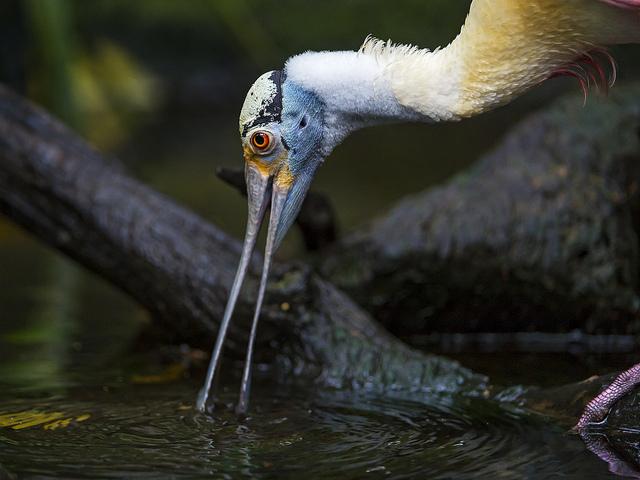What species of bird is this?
Be succinct. Crane. What color is the bird's eye?
Short answer required. Red. What color is the bird's beak?
Short answer required. Gray. Does the bird have a large beak?
Keep it brief. Yes. 